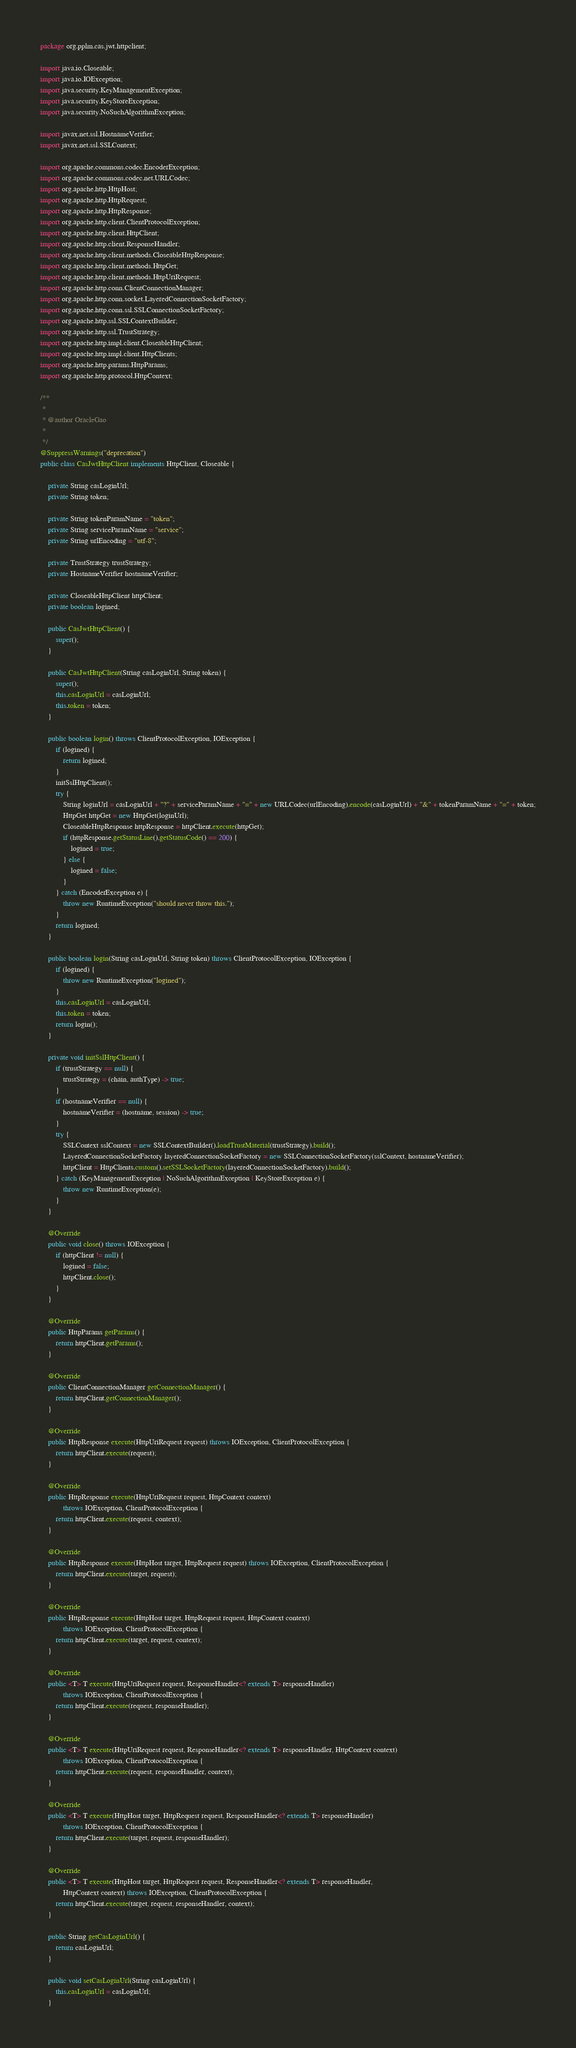<code> <loc_0><loc_0><loc_500><loc_500><_Java_>package org.pplm.cas.jwt.httpclient;

import java.io.Closeable;
import java.io.IOException;
import java.security.KeyManagementException;
import java.security.KeyStoreException;
import java.security.NoSuchAlgorithmException;

import javax.net.ssl.HostnameVerifier;
import javax.net.ssl.SSLContext;

import org.apache.commons.codec.EncoderException;
import org.apache.commons.codec.net.URLCodec;
import org.apache.http.HttpHost;
import org.apache.http.HttpRequest;
import org.apache.http.HttpResponse;
import org.apache.http.client.ClientProtocolException;
import org.apache.http.client.HttpClient;
import org.apache.http.client.ResponseHandler;
import org.apache.http.client.methods.CloseableHttpResponse;
import org.apache.http.client.methods.HttpGet;
import org.apache.http.client.methods.HttpUriRequest;
import org.apache.http.conn.ClientConnectionManager;
import org.apache.http.conn.socket.LayeredConnectionSocketFactory;
import org.apache.http.conn.ssl.SSLConnectionSocketFactory;
import org.apache.http.ssl.SSLContextBuilder;
import org.apache.http.ssl.TrustStrategy;
import org.apache.http.impl.client.CloseableHttpClient;
import org.apache.http.impl.client.HttpClients;
import org.apache.http.params.HttpParams;
import org.apache.http.protocol.HttpContext;

/**
 * 
 * @author OracleGao
 *
 */
@SuppressWarnings("deprecation")
public class CasJwtHttpClient implements HttpClient, Closeable {
	
	private String casLoginUrl;
	private String token;
	
	private String tokenParamName = "token";
	private String serviceParamName = "service";
	private String urlEncoding = "utf-8";
	
	private TrustStrategy trustStrategy;
	private HostnameVerifier hostnameVerifier;
	
	private CloseableHttpClient httpClient;
	private boolean logined;
	
	public CasJwtHttpClient() {
		super();
	}

	public CasJwtHttpClient(String casLoginUrl, String token) {
		super();
		this.casLoginUrl = casLoginUrl;
		this.token = token;
	}
	
	public boolean login() throws ClientProtocolException, IOException {
		if (logined) {
			return logined;
		}
		initSslHttpClient();
		try {
			String loginUrl = casLoginUrl + "?" + serviceParamName + "=" + new URLCodec(urlEncoding).encode(casLoginUrl) + "&" + tokenParamName + "=" + token;
			HttpGet httpGet = new HttpGet(loginUrl);
			CloseableHttpResponse httpResponse = httpClient.execute(httpGet);
			if (httpResponse.getStatusLine().getStatusCode() == 200) {
				logined = true;
			} else {
				logined = false;
			}
		} catch (EncoderException e) {
			throw new RuntimeException("should never throw this.");
		}
		return logined;
	}
	
	public boolean login(String casLoginUrl, String token) throws ClientProtocolException, IOException {
		if (logined) {
			throw new RuntimeException("logined");
		}
		this.casLoginUrl = casLoginUrl;
		this.token = token;
		return login();
	}
	
	private void initSslHttpClient() {
		if (trustStrategy == null) {
			trustStrategy = (chain, authType) -> true;
		}
		if (hostnameVerifier == null) {
			hostnameVerifier = (hostname, session) -> true;
		}
		try {
			SSLContext sslContext = new SSLContextBuilder().loadTrustMaterial(trustStrategy).build();
			LayeredConnectionSocketFactory layeredConnectionSocketFactory = new SSLConnectionSocketFactory(sslContext, hostnameVerifier);
			httpClient = HttpClients.custom().setSSLSocketFactory(layeredConnectionSocketFactory).build();
		} catch (KeyManagementException | NoSuchAlgorithmException | KeyStoreException e) {
			throw new RuntimeException(e);
		}
	}
	
	@Override
	public void close() throws IOException {
		if (httpClient != null) {
			logined = false;
			httpClient.close();
		}
	}

	@Override
	public HttpParams getParams() {
		return httpClient.getParams();
	}

	@Override
	public ClientConnectionManager getConnectionManager() {
		return httpClient.getConnectionManager();
	}

	@Override
	public HttpResponse execute(HttpUriRequest request) throws IOException, ClientProtocolException {
		return httpClient.execute(request);
	}

	@Override
	public HttpResponse execute(HttpUriRequest request, HttpContext context)
			throws IOException, ClientProtocolException {
		return httpClient.execute(request, context);
	}

	@Override
	public HttpResponse execute(HttpHost target, HttpRequest request) throws IOException, ClientProtocolException {
		return httpClient.execute(target, request);
	}

	@Override
	public HttpResponse execute(HttpHost target, HttpRequest request, HttpContext context)
			throws IOException, ClientProtocolException {
		return httpClient.execute(target, request, context);
	}

	@Override
	public <T> T execute(HttpUriRequest request, ResponseHandler<? extends T> responseHandler)
			throws IOException, ClientProtocolException {
		return httpClient.execute(request, responseHandler);
	}

	@Override
	public <T> T execute(HttpUriRequest request, ResponseHandler<? extends T> responseHandler, HttpContext context)
			throws IOException, ClientProtocolException {
		return httpClient.execute(request, responseHandler, context);
	}

	@Override
	public <T> T execute(HttpHost target, HttpRequest request, ResponseHandler<? extends T> responseHandler)
			throws IOException, ClientProtocolException {
		return httpClient.execute(target, request, responseHandler);
	}

	@Override
	public <T> T execute(HttpHost target, HttpRequest request, ResponseHandler<? extends T> responseHandler,
			HttpContext context) throws IOException, ClientProtocolException {
		return httpClient.execute(target, request, responseHandler, context);
	}

	public String getCasLoginUrl() {
		return casLoginUrl;
	}

	public void setCasLoginUrl(String casLoginUrl) {
		this.casLoginUrl = casLoginUrl;
	}
</code> 